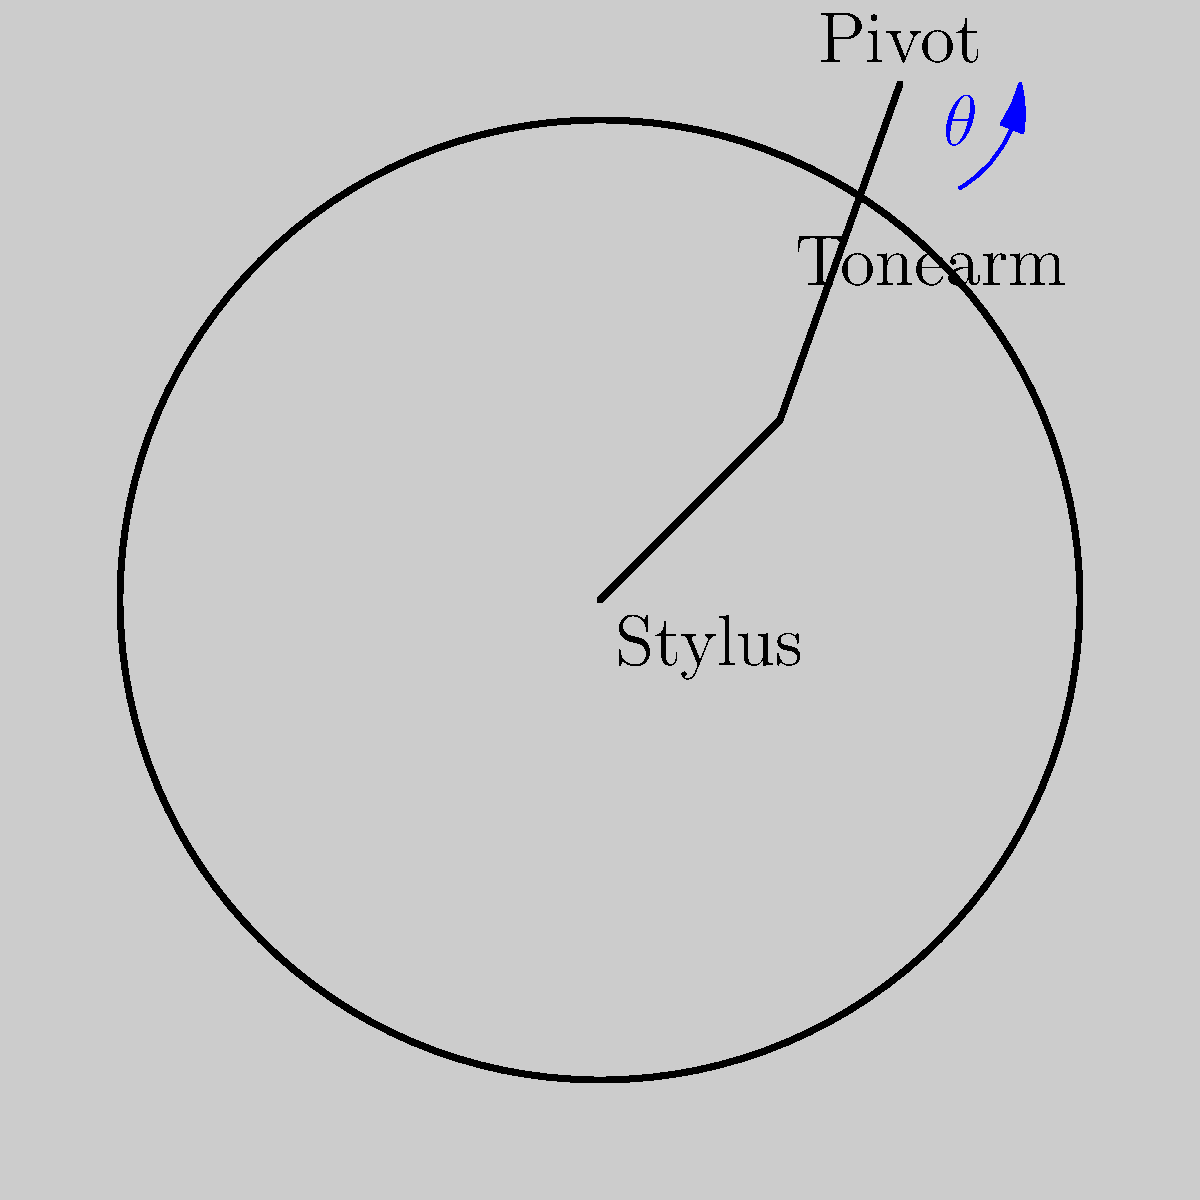When you drop the needle on your favorite vinyl, the tonearm moves in an arc. If the tonearm is 20 cm long and moves through an angle of 30°, how far does the stylus (needle) travel along the surface of the record? (Assume the motion is in a perfect circular arc.) Let's break this down step-by-step:

1) The tonearm's motion forms part of a circle, with the tonearm length as the radius.

2) The formula for the length of an arc is:
   
   $s = r\theta$

   Where:
   $s$ = arc length (distance traveled by the stylus)
   $r$ = radius (length of the tonearm)
   $\theta$ = angle in radians

3) We're given the angle in degrees (30°), but we need it in radians. To convert:
   
   $\theta \text{ (in radians)} = \frac{\pi}{180°} \times \theta \text{ (in degrees)}$
   
   $\theta = \frac{\pi}{180°} \times 30° = \frac{\pi}{6}$ radians

4) Now we can plug into our arc length formula:

   $s = r\theta = 20 \text{ cm} \times \frac{\pi}{6}$

5) Simplify:
   
   $s = \frac{20\pi}{6} \text{ cm} \approx 10.47 \text{ cm}$

So, the stylus travels approximately 10.47 cm along the surface of the record.
Answer: 10.47 cm 